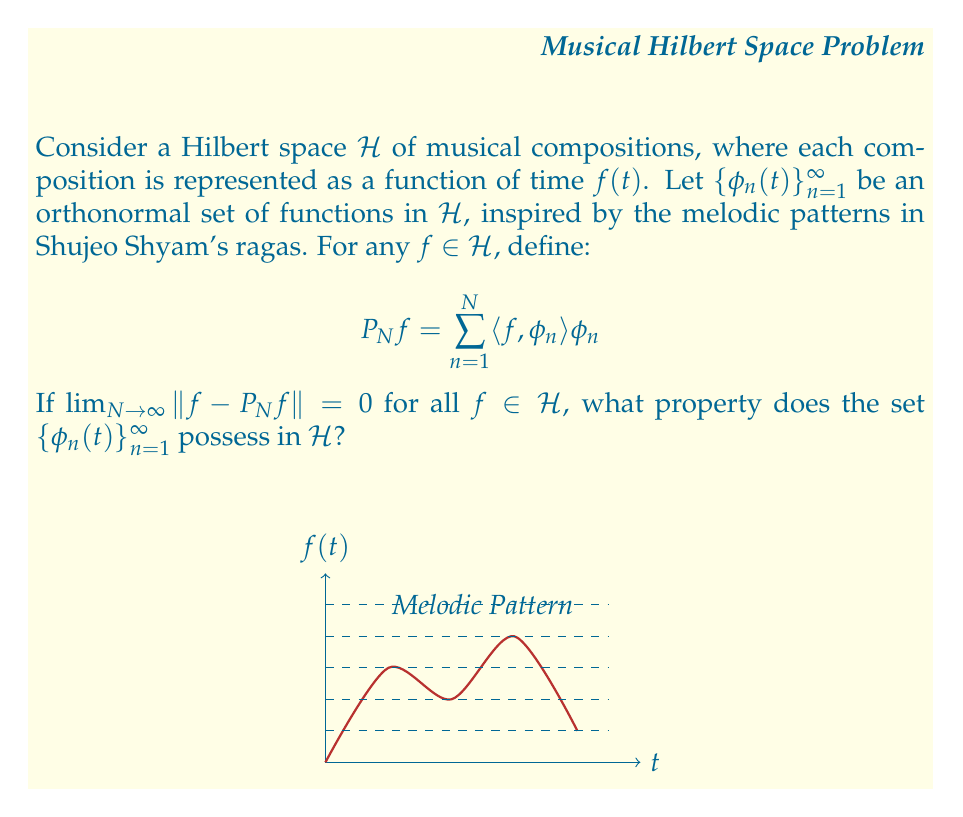Provide a solution to this math problem. Let's break this down step-by-step:

1) The question is asking about a property of the set $\{\phi_n(t)\}_{n=1}^{\infty}$ in the Hilbert space $\mathcal{H}$ of musical compositions.

2) We're given that $\lim_{N \to \infty} \|f - P_N f\| = 0$ for all $f \in \mathcal{H}$, where $P_N f = \sum_{n=1}^N \langle f, \phi_n \rangle \phi_n$.

3) This condition means that any function $f$ in $\mathcal{H}$ can be approximated arbitrarily closely by a finite linear combination of the $\phi_n$ functions.

4) In other words, the partial sums of the series $\sum_{n=1}^{\infty} \langle f, \phi_n \rangle \phi_n$ converge to $f$ in the norm topology of $\mathcal{H}$.

5) This property is precisely the definition of completeness for an orthonormal set in a Hilbert space.

6) When an orthonormal set is complete, it forms an orthonormal basis for the Hilbert space.

7) In the context of musical compositions, this means that any musical piece in $\mathcal{H}$ can be expressed as a (potentially infinite) linear combination of the basic melodic patterns represented by the $\phi_n$ functions.

8) The completeness property ensures that these basic patterns are sufficient to represent all possible compositions in the space, much like how Shujeo Shyam's ragas form a complete musical system.

Therefore, the set $\{\phi_n(t)\}_{n=1}^{\infty}$ possesses the property of completeness in $\mathcal{H}$.
Answer: Completeness 